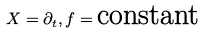Convert formula to latex. <formula><loc_0><loc_0><loc_500><loc_500>X = \partial _ { t } , f = \text {constant}</formula> 